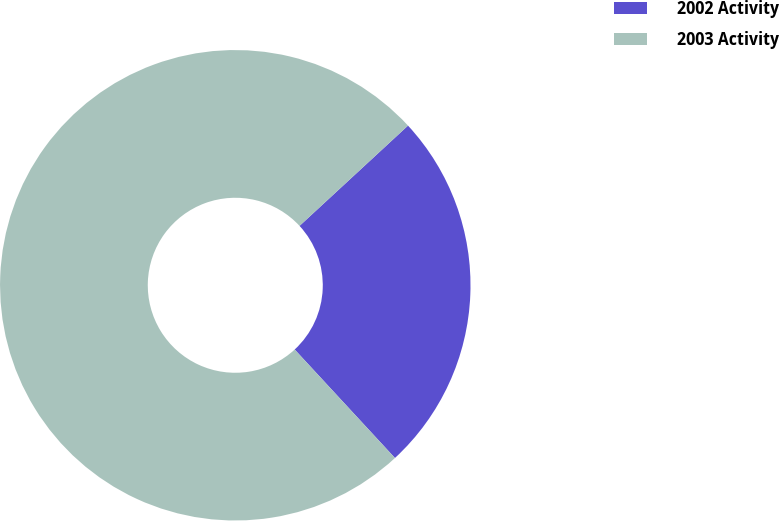<chart> <loc_0><loc_0><loc_500><loc_500><pie_chart><fcel>2002 Activity<fcel>2003 Activity<nl><fcel>25.0%<fcel>75.0%<nl></chart> 